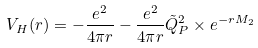Convert formula to latex. <formula><loc_0><loc_0><loc_500><loc_500>V _ { H } ( r ) = - \frac { e ^ { 2 } } { 4 \pi r } - \frac { e ^ { 2 } } { 4 \pi r } \tilde { Q } _ { P } ^ { 2 } \times e ^ { - r M _ { 2 } }</formula> 